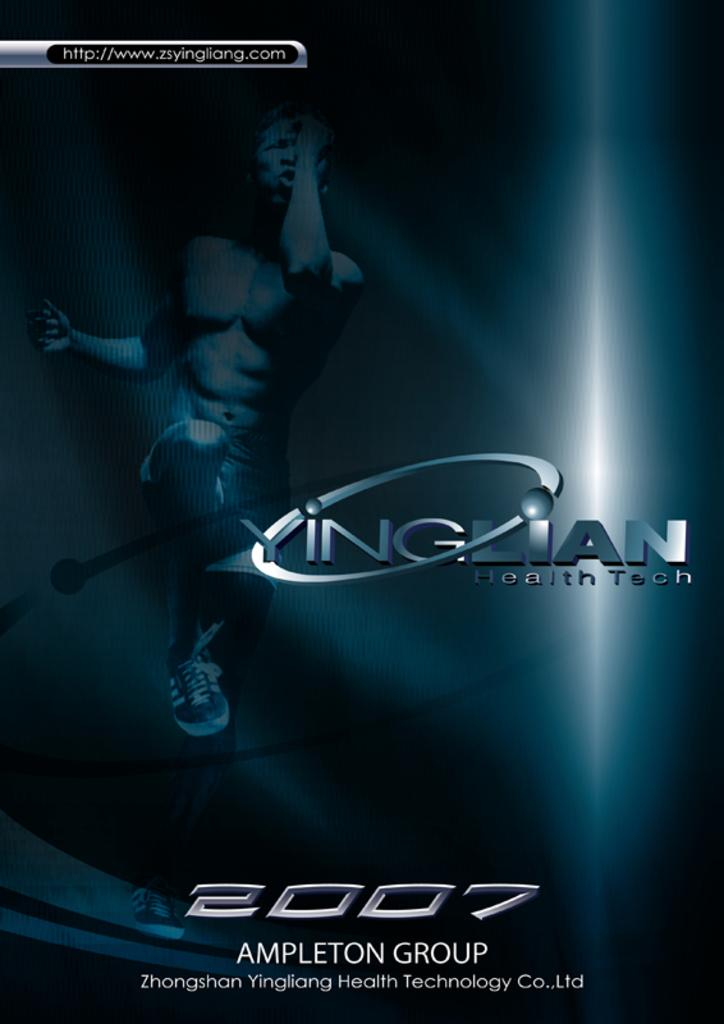<image>
Provide a brief description of the given image. Yinglian health tech 2008 poster from the Ampleton Group 